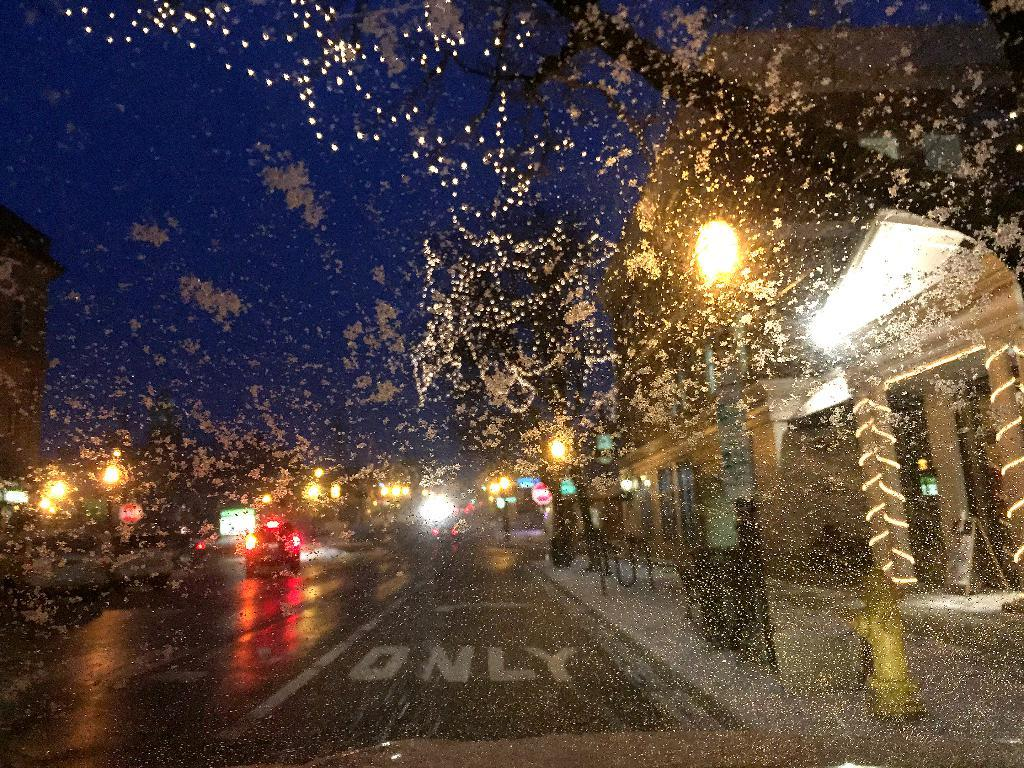What is the main feature of the image? There is a road in the image. What is happening on the road? There are vehicles on the road. What structure can be seen on the right side of the image? There is a shed on the right side of the image. What can be used to illuminate the scene in the image? Lights are visible in the image. What part of the natural environment is visible in the image? There is sky visible in the background of the image. Where is the playground located in the image? There is no playground present in the image. Can you see any jellyfish swimming in the sky in the image? There are no jellyfish visible in the image; only vehicles, a shed, lights, and the sky can be seen. 